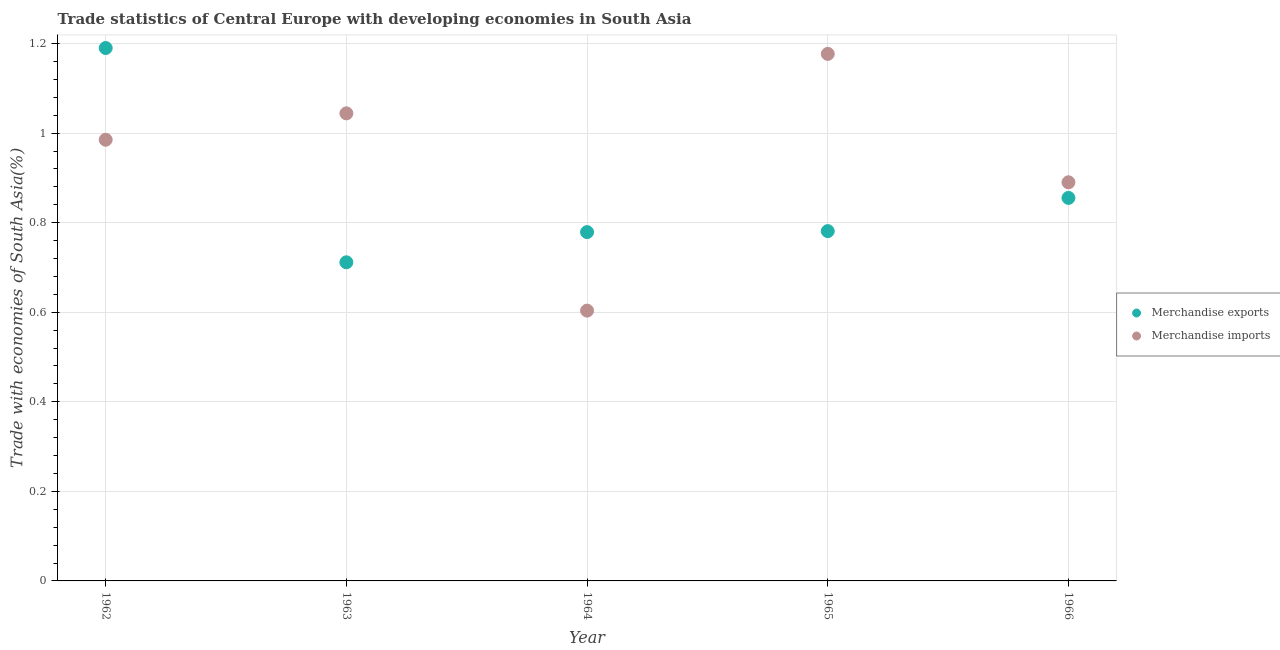How many different coloured dotlines are there?
Your answer should be compact. 2. What is the merchandise imports in 1964?
Provide a succinct answer. 0.6. Across all years, what is the maximum merchandise imports?
Your answer should be very brief. 1.18. Across all years, what is the minimum merchandise exports?
Give a very brief answer. 0.71. What is the total merchandise exports in the graph?
Offer a very short reply. 4.32. What is the difference between the merchandise imports in 1962 and that in 1964?
Your answer should be compact. 0.38. What is the difference between the merchandise imports in 1963 and the merchandise exports in 1965?
Make the answer very short. 0.26. What is the average merchandise exports per year?
Offer a very short reply. 0.86. In the year 1963, what is the difference between the merchandise exports and merchandise imports?
Keep it short and to the point. -0.33. What is the ratio of the merchandise imports in 1962 to that in 1966?
Ensure brevity in your answer.  1.11. Is the merchandise imports in 1965 less than that in 1966?
Your answer should be very brief. No. Is the difference between the merchandise imports in 1964 and 1966 greater than the difference between the merchandise exports in 1964 and 1966?
Offer a terse response. No. What is the difference between the highest and the second highest merchandise exports?
Make the answer very short. 0.33. What is the difference between the highest and the lowest merchandise imports?
Your answer should be very brief. 0.57. In how many years, is the merchandise imports greater than the average merchandise imports taken over all years?
Offer a very short reply. 3. How many dotlines are there?
Your answer should be very brief. 2. How many years are there in the graph?
Your response must be concise. 5. Where does the legend appear in the graph?
Provide a succinct answer. Center right. How many legend labels are there?
Give a very brief answer. 2. How are the legend labels stacked?
Your answer should be very brief. Vertical. What is the title of the graph?
Your response must be concise. Trade statistics of Central Europe with developing economies in South Asia. Does "Urban agglomerations" appear as one of the legend labels in the graph?
Your answer should be very brief. No. What is the label or title of the Y-axis?
Give a very brief answer. Trade with economies of South Asia(%). What is the Trade with economies of South Asia(%) of Merchandise exports in 1962?
Make the answer very short. 1.19. What is the Trade with economies of South Asia(%) of Merchandise imports in 1962?
Make the answer very short. 0.99. What is the Trade with economies of South Asia(%) of Merchandise exports in 1963?
Keep it short and to the point. 0.71. What is the Trade with economies of South Asia(%) in Merchandise imports in 1963?
Provide a short and direct response. 1.04. What is the Trade with economies of South Asia(%) in Merchandise exports in 1964?
Give a very brief answer. 0.78. What is the Trade with economies of South Asia(%) of Merchandise imports in 1964?
Your response must be concise. 0.6. What is the Trade with economies of South Asia(%) of Merchandise exports in 1965?
Keep it short and to the point. 0.78. What is the Trade with economies of South Asia(%) of Merchandise imports in 1965?
Provide a short and direct response. 1.18. What is the Trade with economies of South Asia(%) in Merchandise exports in 1966?
Keep it short and to the point. 0.86. What is the Trade with economies of South Asia(%) of Merchandise imports in 1966?
Offer a very short reply. 0.89. Across all years, what is the maximum Trade with economies of South Asia(%) of Merchandise exports?
Provide a succinct answer. 1.19. Across all years, what is the maximum Trade with economies of South Asia(%) of Merchandise imports?
Provide a succinct answer. 1.18. Across all years, what is the minimum Trade with economies of South Asia(%) of Merchandise exports?
Offer a terse response. 0.71. Across all years, what is the minimum Trade with economies of South Asia(%) of Merchandise imports?
Your response must be concise. 0.6. What is the total Trade with economies of South Asia(%) of Merchandise exports in the graph?
Make the answer very short. 4.32. What is the total Trade with economies of South Asia(%) in Merchandise imports in the graph?
Give a very brief answer. 4.7. What is the difference between the Trade with economies of South Asia(%) in Merchandise exports in 1962 and that in 1963?
Your answer should be compact. 0.48. What is the difference between the Trade with economies of South Asia(%) of Merchandise imports in 1962 and that in 1963?
Provide a succinct answer. -0.06. What is the difference between the Trade with economies of South Asia(%) in Merchandise exports in 1962 and that in 1964?
Provide a short and direct response. 0.41. What is the difference between the Trade with economies of South Asia(%) in Merchandise imports in 1962 and that in 1964?
Make the answer very short. 0.38. What is the difference between the Trade with economies of South Asia(%) of Merchandise exports in 1962 and that in 1965?
Offer a terse response. 0.41. What is the difference between the Trade with economies of South Asia(%) in Merchandise imports in 1962 and that in 1965?
Give a very brief answer. -0.19. What is the difference between the Trade with economies of South Asia(%) of Merchandise exports in 1962 and that in 1966?
Make the answer very short. 0.33. What is the difference between the Trade with economies of South Asia(%) of Merchandise imports in 1962 and that in 1966?
Your answer should be very brief. 0.1. What is the difference between the Trade with economies of South Asia(%) of Merchandise exports in 1963 and that in 1964?
Keep it short and to the point. -0.07. What is the difference between the Trade with economies of South Asia(%) in Merchandise imports in 1963 and that in 1964?
Your answer should be very brief. 0.44. What is the difference between the Trade with economies of South Asia(%) in Merchandise exports in 1963 and that in 1965?
Offer a terse response. -0.07. What is the difference between the Trade with economies of South Asia(%) in Merchandise imports in 1963 and that in 1965?
Keep it short and to the point. -0.13. What is the difference between the Trade with economies of South Asia(%) of Merchandise exports in 1963 and that in 1966?
Make the answer very short. -0.14. What is the difference between the Trade with economies of South Asia(%) in Merchandise imports in 1963 and that in 1966?
Your answer should be very brief. 0.15. What is the difference between the Trade with economies of South Asia(%) of Merchandise exports in 1964 and that in 1965?
Your answer should be very brief. -0. What is the difference between the Trade with economies of South Asia(%) of Merchandise imports in 1964 and that in 1965?
Make the answer very short. -0.57. What is the difference between the Trade with economies of South Asia(%) of Merchandise exports in 1964 and that in 1966?
Offer a terse response. -0.08. What is the difference between the Trade with economies of South Asia(%) of Merchandise imports in 1964 and that in 1966?
Your response must be concise. -0.29. What is the difference between the Trade with economies of South Asia(%) in Merchandise exports in 1965 and that in 1966?
Keep it short and to the point. -0.07. What is the difference between the Trade with economies of South Asia(%) in Merchandise imports in 1965 and that in 1966?
Provide a short and direct response. 0.29. What is the difference between the Trade with economies of South Asia(%) of Merchandise exports in 1962 and the Trade with economies of South Asia(%) of Merchandise imports in 1963?
Offer a terse response. 0.15. What is the difference between the Trade with economies of South Asia(%) in Merchandise exports in 1962 and the Trade with economies of South Asia(%) in Merchandise imports in 1964?
Your answer should be very brief. 0.59. What is the difference between the Trade with economies of South Asia(%) of Merchandise exports in 1962 and the Trade with economies of South Asia(%) of Merchandise imports in 1965?
Provide a short and direct response. 0.01. What is the difference between the Trade with economies of South Asia(%) of Merchandise exports in 1962 and the Trade with economies of South Asia(%) of Merchandise imports in 1966?
Offer a terse response. 0.3. What is the difference between the Trade with economies of South Asia(%) of Merchandise exports in 1963 and the Trade with economies of South Asia(%) of Merchandise imports in 1964?
Your answer should be compact. 0.11. What is the difference between the Trade with economies of South Asia(%) of Merchandise exports in 1963 and the Trade with economies of South Asia(%) of Merchandise imports in 1965?
Provide a succinct answer. -0.47. What is the difference between the Trade with economies of South Asia(%) of Merchandise exports in 1963 and the Trade with economies of South Asia(%) of Merchandise imports in 1966?
Ensure brevity in your answer.  -0.18. What is the difference between the Trade with economies of South Asia(%) in Merchandise exports in 1964 and the Trade with economies of South Asia(%) in Merchandise imports in 1965?
Provide a short and direct response. -0.4. What is the difference between the Trade with economies of South Asia(%) of Merchandise exports in 1964 and the Trade with economies of South Asia(%) of Merchandise imports in 1966?
Offer a very short reply. -0.11. What is the difference between the Trade with economies of South Asia(%) in Merchandise exports in 1965 and the Trade with economies of South Asia(%) in Merchandise imports in 1966?
Ensure brevity in your answer.  -0.11. What is the average Trade with economies of South Asia(%) in Merchandise exports per year?
Your answer should be very brief. 0.86. What is the average Trade with economies of South Asia(%) in Merchandise imports per year?
Offer a terse response. 0.94. In the year 1962, what is the difference between the Trade with economies of South Asia(%) of Merchandise exports and Trade with economies of South Asia(%) of Merchandise imports?
Your answer should be compact. 0.2. In the year 1963, what is the difference between the Trade with economies of South Asia(%) of Merchandise exports and Trade with economies of South Asia(%) of Merchandise imports?
Your answer should be very brief. -0.33. In the year 1964, what is the difference between the Trade with economies of South Asia(%) in Merchandise exports and Trade with economies of South Asia(%) in Merchandise imports?
Offer a terse response. 0.18. In the year 1965, what is the difference between the Trade with economies of South Asia(%) of Merchandise exports and Trade with economies of South Asia(%) of Merchandise imports?
Provide a succinct answer. -0.4. In the year 1966, what is the difference between the Trade with economies of South Asia(%) of Merchandise exports and Trade with economies of South Asia(%) of Merchandise imports?
Provide a succinct answer. -0.03. What is the ratio of the Trade with economies of South Asia(%) in Merchandise exports in 1962 to that in 1963?
Make the answer very short. 1.67. What is the ratio of the Trade with economies of South Asia(%) in Merchandise imports in 1962 to that in 1963?
Provide a short and direct response. 0.94. What is the ratio of the Trade with economies of South Asia(%) of Merchandise exports in 1962 to that in 1964?
Your response must be concise. 1.53. What is the ratio of the Trade with economies of South Asia(%) of Merchandise imports in 1962 to that in 1964?
Your response must be concise. 1.63. What is the ratio of the Trade with economies of South Asia(%) in Merchandise exports in 1962 to that in 1965?
Ensure brevity in your answer.  1.52. What is the ratio of the Trade with economies of South Asia(%) of Merchandise imports in 1962 to that in 1965?
Offer a terse response. 0.84. What is the ratio of the Trade with economies of South Asia(%) in Merchandise exports in 1962 to that in 1966?
Provide a succinct answer. 1.39. What is the ratio of the Trade with economies of South Asia(%) in Merchandise imports in 1962 to that in 1966?
Provide a succinct answer. 1.11. What is the ratio of the Trade with economies of South Asia(%) of Merchandise exports in 1963 to that in 1964?
Provide a succinct answer. 0.91. What is the ratio of the Trade with economies of South Asia(%) in Merchandise imports in 1963 to that in 1964?
Give a very brief answer. 1.73. What is the ratio of the Trade with economies of South Asia(%) in Merchandise exports in 1963 to that in 1965?
Offer a terse response. 0.91. What is the ratio of the Trade with economies of South Asia(%) in Merchandise imports in 1963 to that in 1965?
Your response must be concise. 0.89. What is the ratio of the Trade with economies of South Asia(%) of Merchandise exports in 1963 to that in 1966?
Make the answer very short. 0.83. What is the ratio of the Trade with economies of South Asia(%) of Merchandise imports in 1963 to that in 1966?
Keep it short and to the point. 1.17. What is the ratio of the Trade with economies of South Asia(%) of Merchandise exports in 1964 to that in 1965?
Keep it short and to the point. 1. What is the ratio of the Trade with economies of South Asia(%) of Merchandise imports in 1964 to that in 1965?
Your answer should be very brief. 0.51. What is the ratio of the Trade with economies of South Asia(%) in Merchandise exports in 1964 to that in 1966?
Offer a terse response. 0.91. What is the ratio of the Trade with economies of South Asia(%) in Merchandise imports in 1964 to that in 1966?
Provide a short and direct response. 0.68. What is the ratio of the Trade with economies of South Asia(%) in Merchandise exports in 1965 to that in 1966?
Ensure brevity in your answer.  0.91. What is the ratio of the Trade with economies of South Asia(%) in Merchandise imports in 1965 to that in 1966?
Make the answer very short. 1.32. What is the difference between the highest and the second highest Trade with economies of South Asia(%) of Merchandise exports?
Provide a succinct answer. 0.33. What is the difference between the highest and the second highest Trade with economies of South Asia(%) of Merchandise imports?
Provide a short and direct response. 0.13. What is the difference between the highest and the lowest Trade with economies of South Asia(%) of Merchandise exports?
Make the answer very short. 0.48. What is the difference between the highest and the lowest Trade with economies of South Asia(%) of Merchandise imports?
Provide a succinct answer. 0.57. 